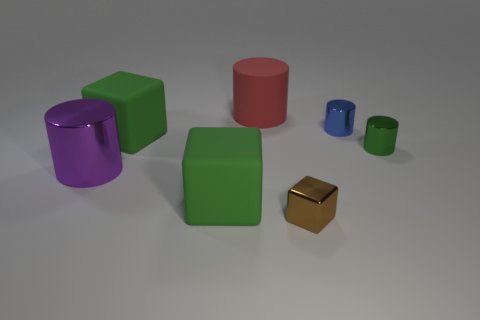Subtract all matte cubes. How many cubes are left? 1 Add 2 small metallic cylinders. How many objects exist? 9 Subtract all green cubes. How many cubes are left? 1 Subtract 1 blocks. How many blocks are left? 2 Subtract all cylinders. How many objects are left? 3 Add 1 big red matte cylinders. How many big red matte cylinders exist? 2 Subtract 0 yellow spheres. How many objects are left? 7 Subtract all red blocks. Subtract all cyan balls. How many blocks are left? 3 Subtract all gray cubes. How many green cylinders are left? 1 Subtract all big rubber balls. Subtract all large red rubber objects. How many objects are left? 6 